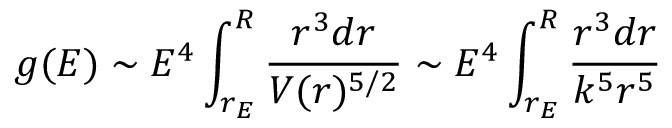Convert formula to latex. <formula><loc_0><loc_0><loc_500><loc_500>g ( E ) \sim E ^ { 4 } \int _ { r _ { E } } ^ { R } { \frac { r ^ { 3 } d r } { V ( r ) ^ { 5 / 2 } } } \sim E ^ { 4 } \int _ { r _ { E } } ^ { R } { \frac { r ^ { 3 } d r } { k ^ { 5 } r ^ { 5 } } }</formula> 